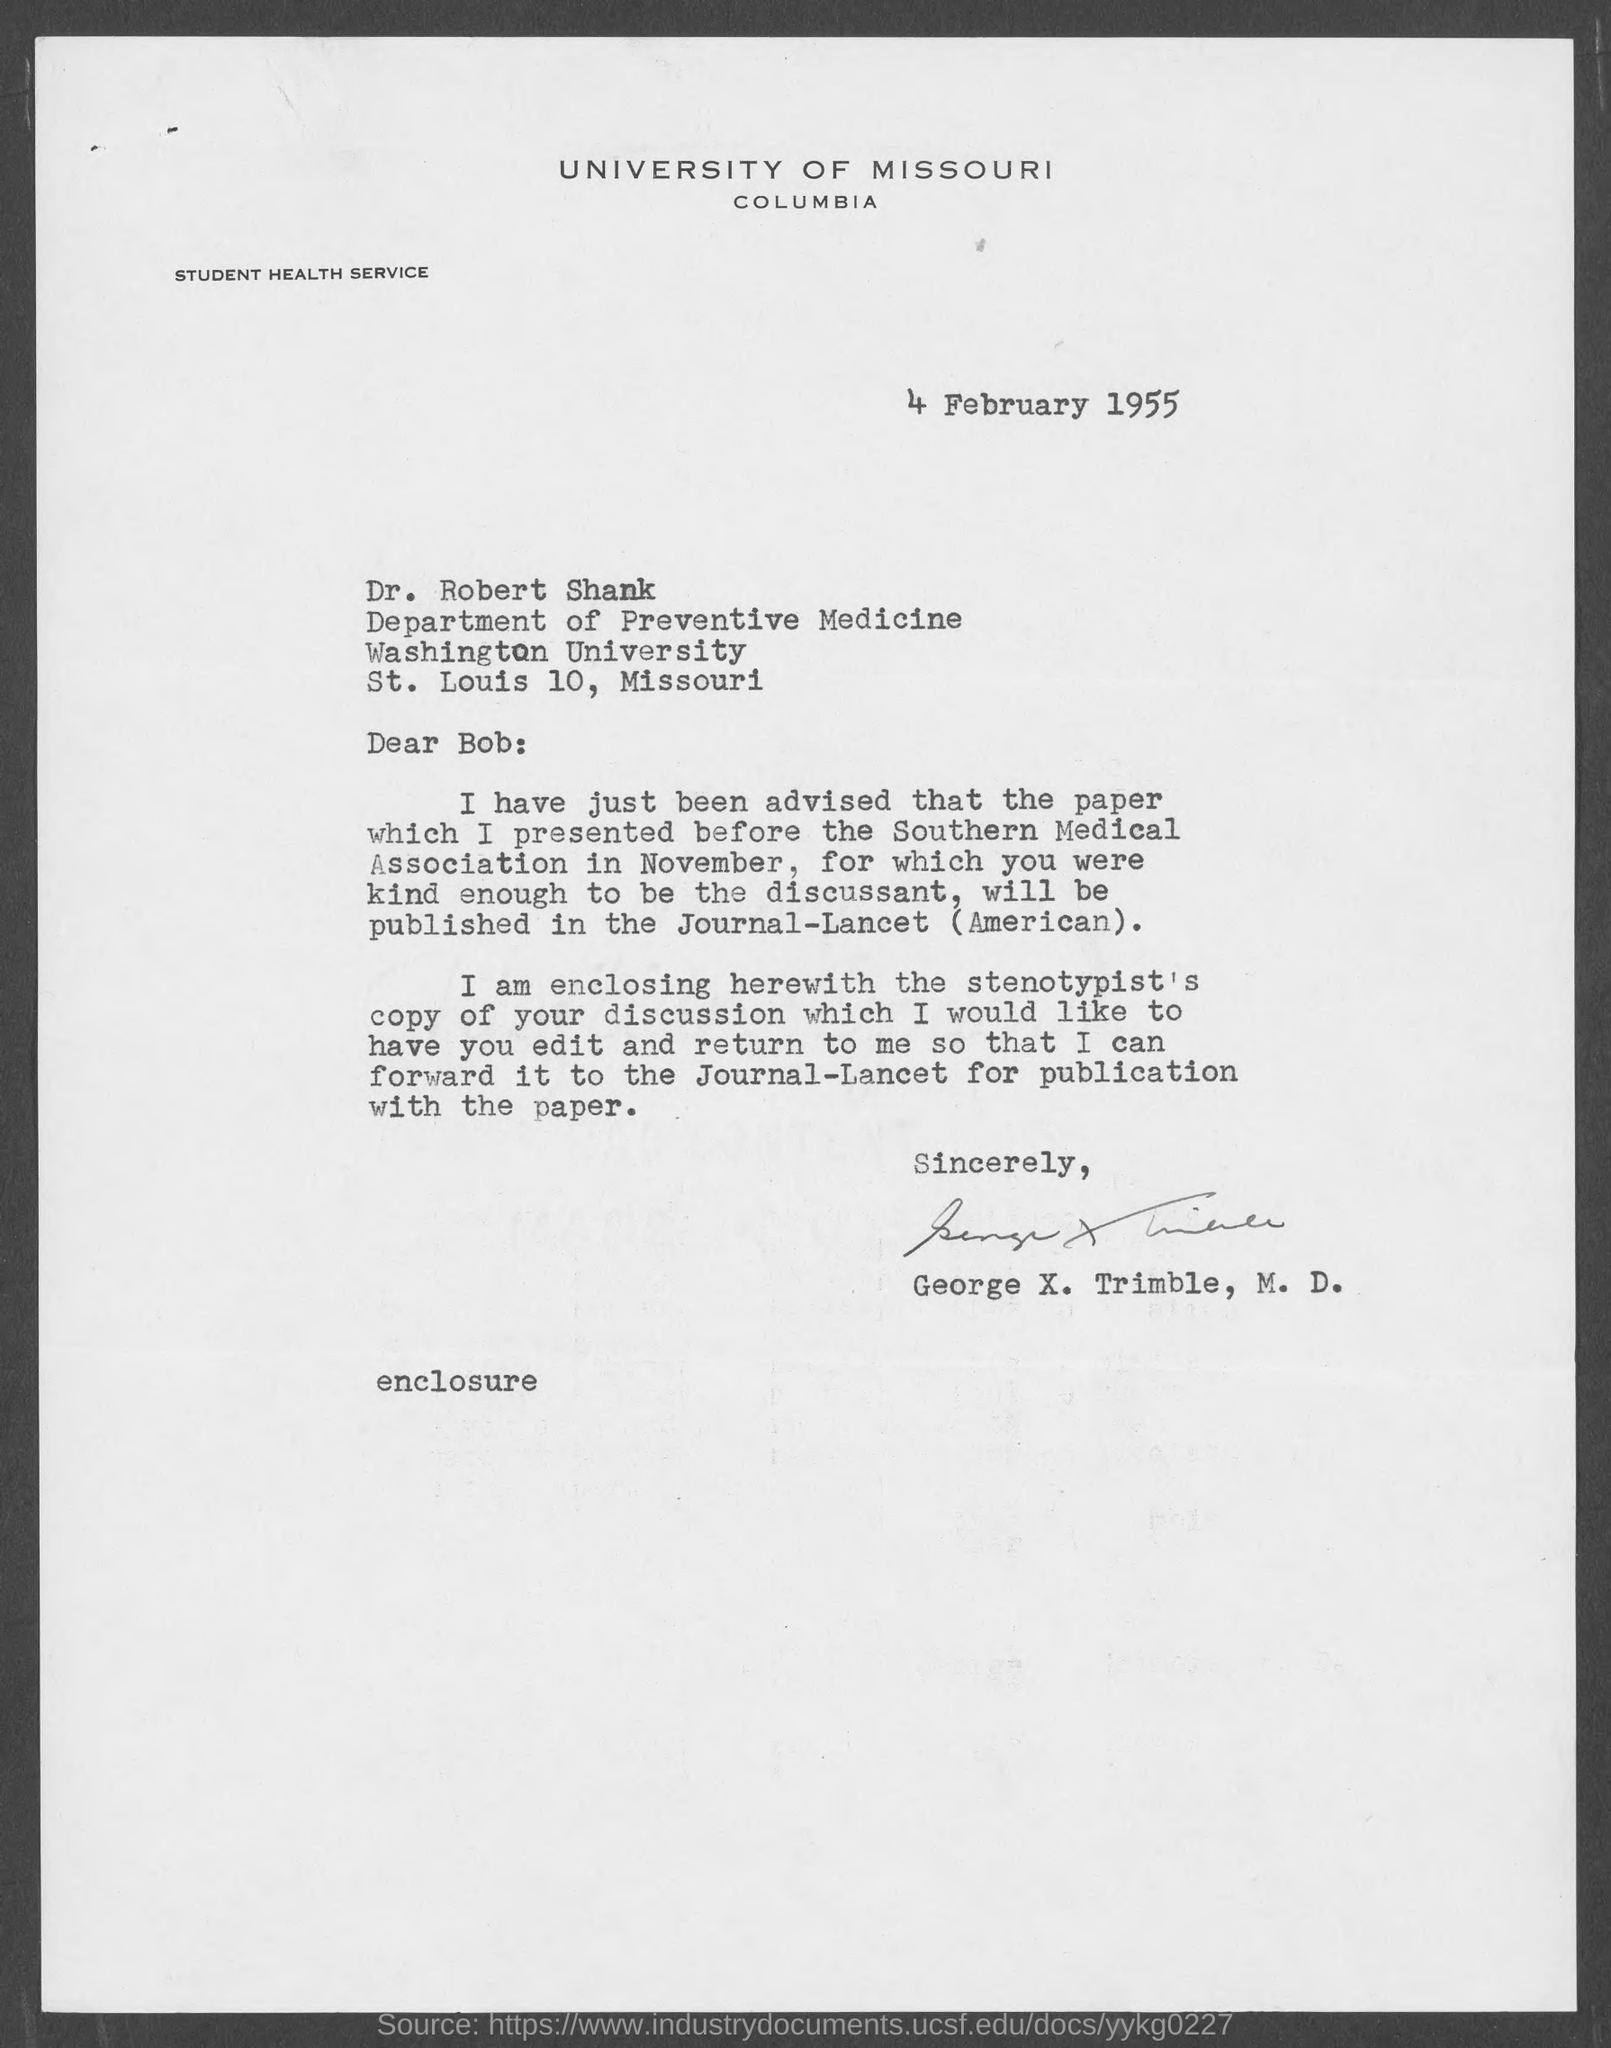Highlight a few significant elements in this photo. The letter is addressed to Dr. Robert Shank. The letter was written by George X. Trimble, M.D. The letter is dated on February 4, 1955. Dr. Robert Shank is affiliated with the Department of Preventive Medicine. The address of Washington University is located in St. Louis, Missouri. 